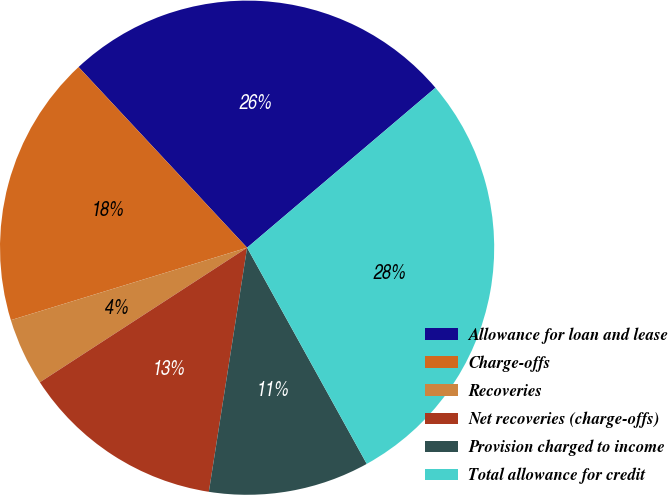<chart> <loc_0><loc_0><loc_500><loc_500><pie_chart><fcel>Allowance for loan and lease<fcel>Charge-offs<fcel>Recoveries<fcel>Net recoveries (charge-offs)<fcel>Provision charged to income<fcel>Total allowance for credit<nl><fcel>25.74%<fcel>17.79%<fcel>4.43%<fcel>13.36%<fcel>10.52%<fcel>28.16%<nl></chart> 